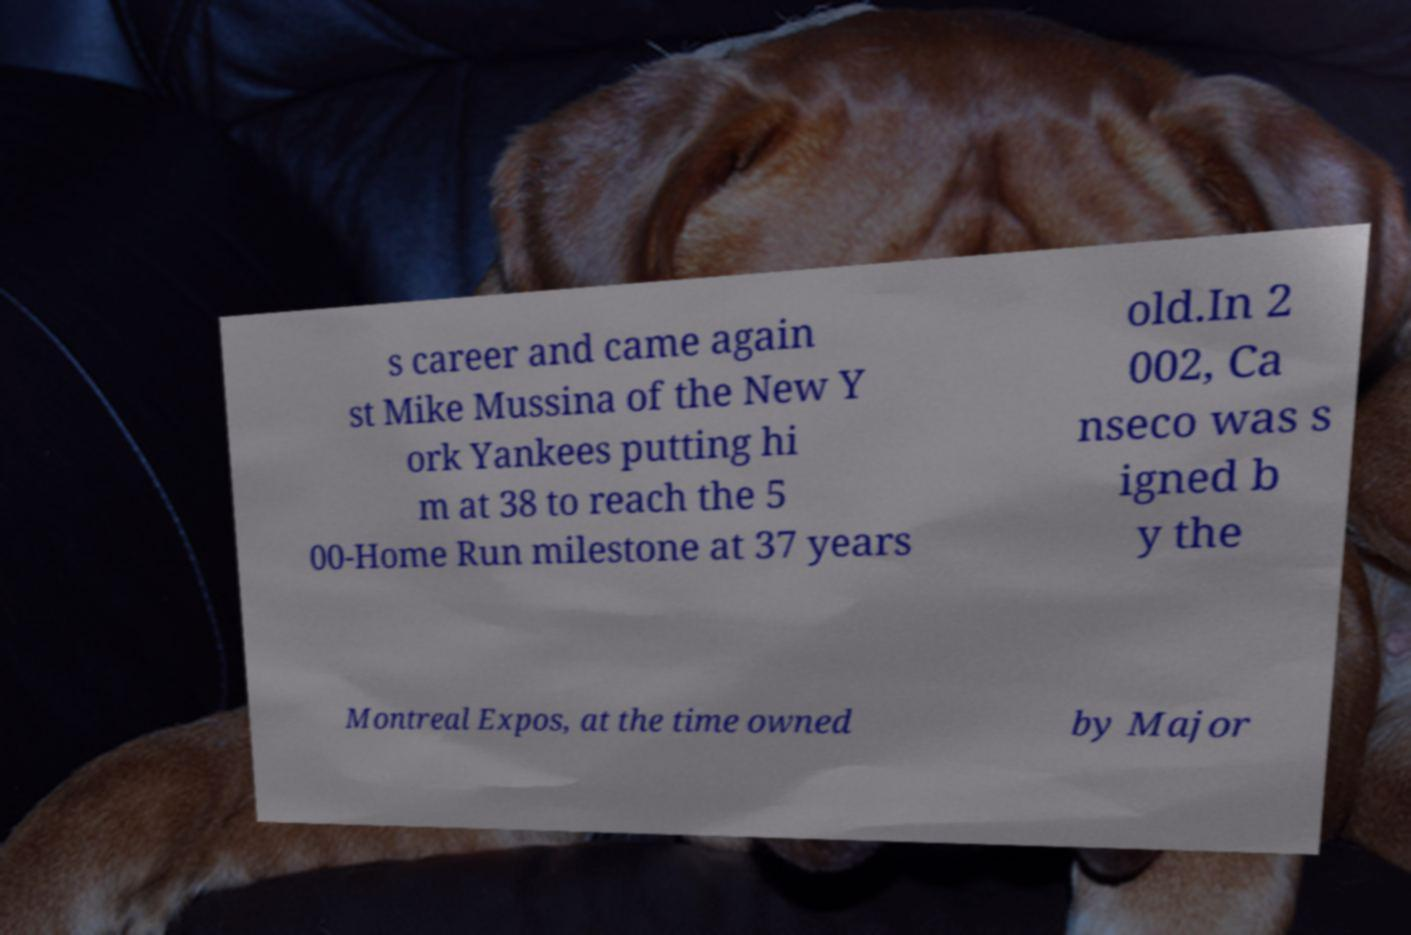Could you extract and type out the text from this image? s career and came again st Mike Mussina of the New Y ork Yankees putting hi m at 38 to reach the 5 00-Home Run milestone at 37 years old.In 2 002, Ca nseco was s igned b y the Montreal Expos, at the time owned by Major 